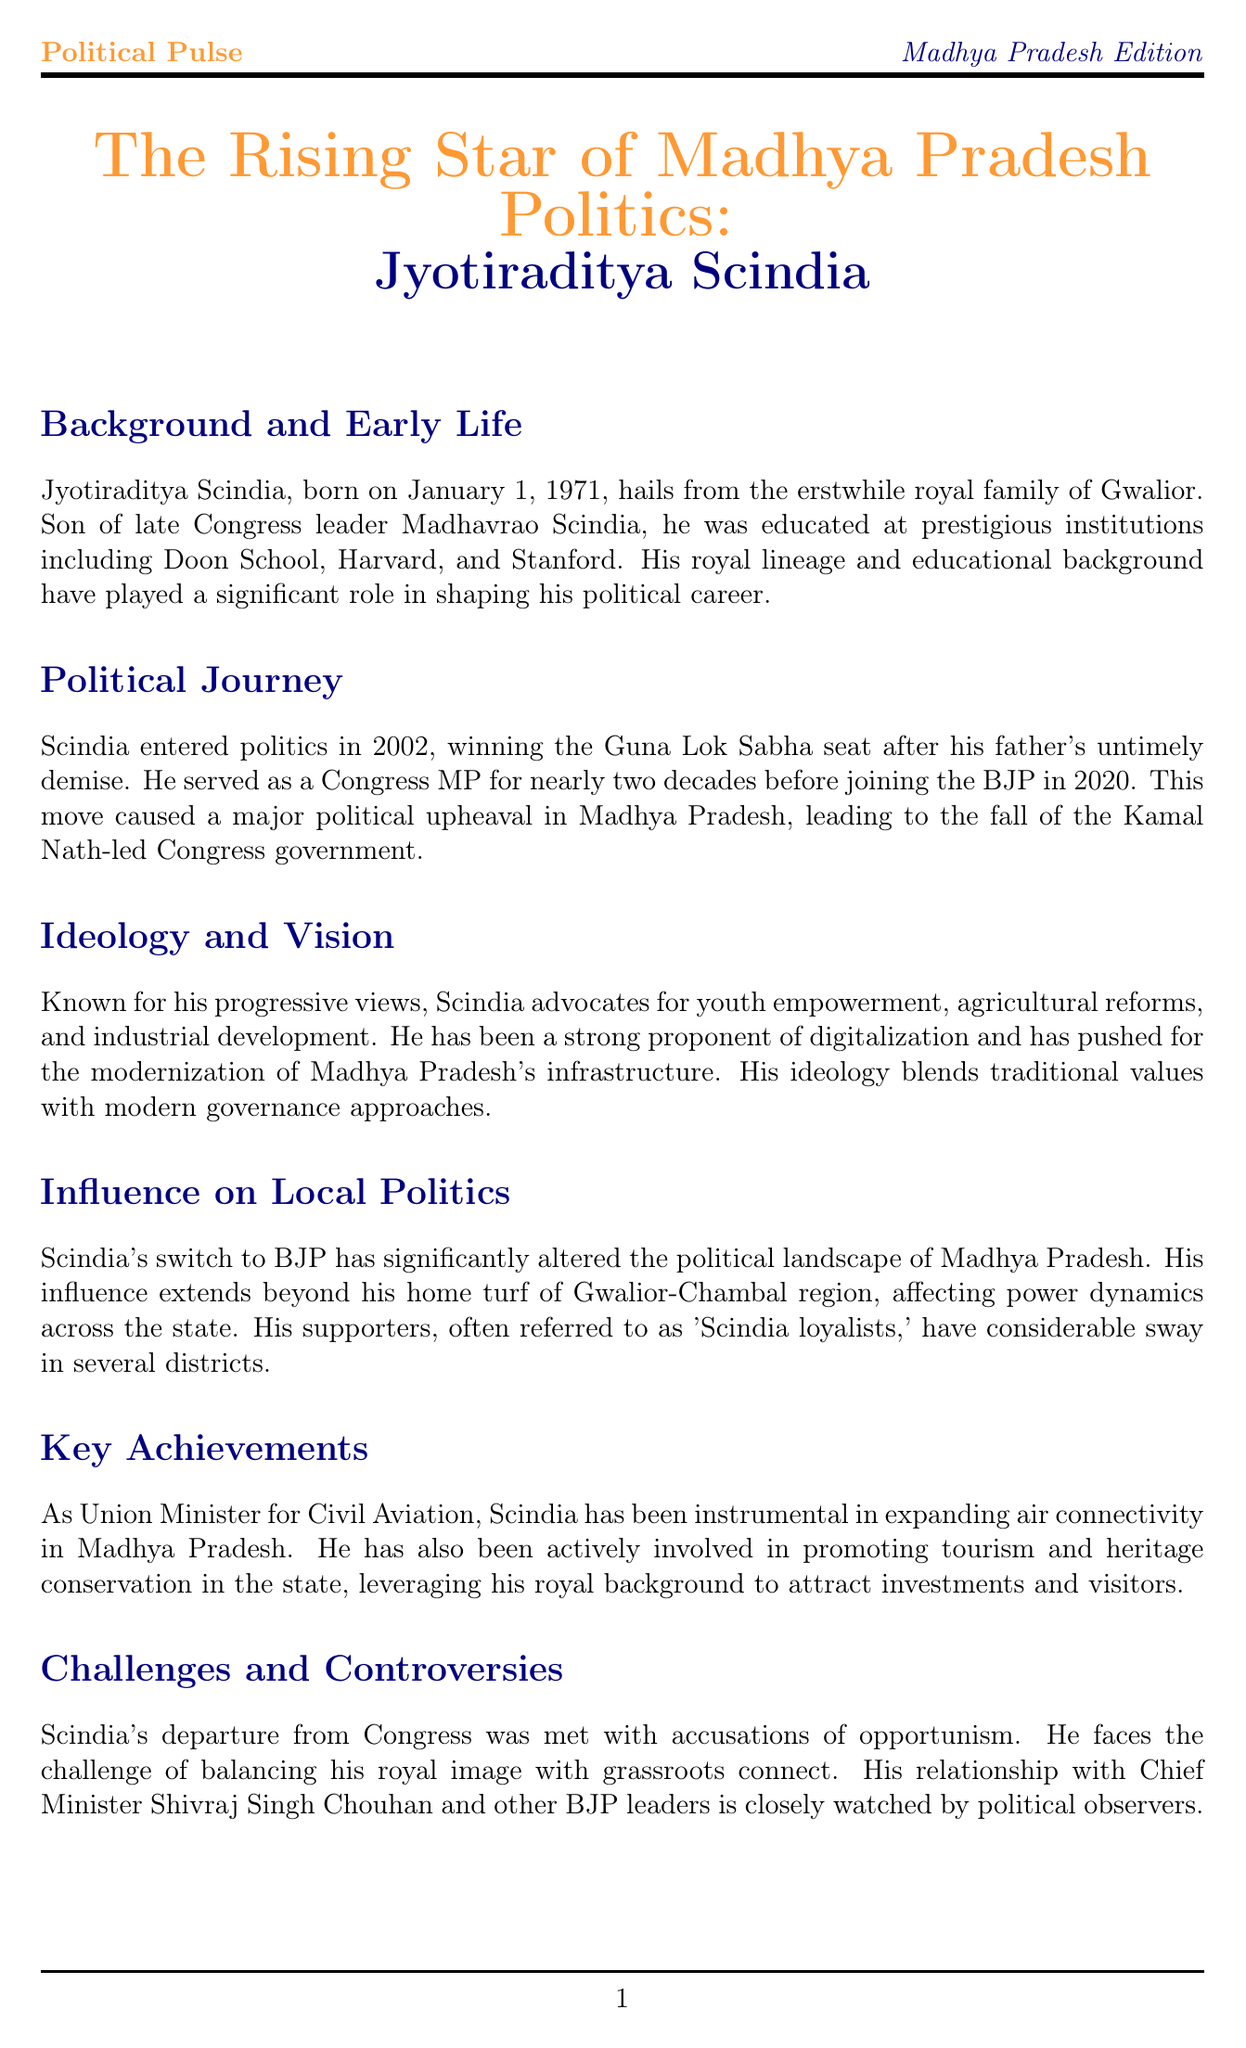What is Jyotiraditya Scindia's date of birth? The document states that Jyotiraditya Scindia was born on January 1, 1971.
Answer: January 1, 1971 Which political party did Scindia join in 2020? The document mentions that Scindia joined the BJP in 2020.
Answer: BJP What position did Scindia hold as Union Minister? The document specifies that he was the Union Minister for Civil Aviation.
Answer: Civil Aviation What are the two areas of focus in Scindia's ideology? The document outlines that he advocates for youth empowerment and agricultural reforms.
Answer: Youth empowerment, agricultural reforms What significant political change resulted from Scindia's switch to BJP? The document indicates that his move caused the fall of the Kamal Nath-led Congress government.
Answer: Fall of the Kamal Nath-led Congress government Who is regarded as a political analyst in the document? The document attributes the analysis to Dr. Yatindra Singh Sisodia from the Madhya Pradesh Institute of Social Science Research.
Answer: Dr. Yatindra Singh Sisodia What is a notable challenge mentioned for Scindia? The document discusses the challenge of balancing his royal image with grassroots connect.
Answer: Balancing royal image with grassroots connect What is the main theme of the newsletter? The document title indicates the main theme is Jyotiraditya Scindia as a rising star in Madhya Pradesh politics.
Answer: Jyotiraditya Scindia as a rising star in Madhya Pradesh politics 